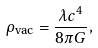<formula> <loc_0><loc_0><loc_500><loc_500>\rho _ { \text {vac} } = \frac { \lambda c ^ { 4 } } { 8 \pi G } ,</formula> 